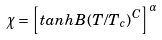<formula> <loc_0><loc_0><loc_500><loc_500>\chi = \left [ t a n h B ( T / T _ { c } ) ^ { C } \right ] ^ { \alpha }</formula> 